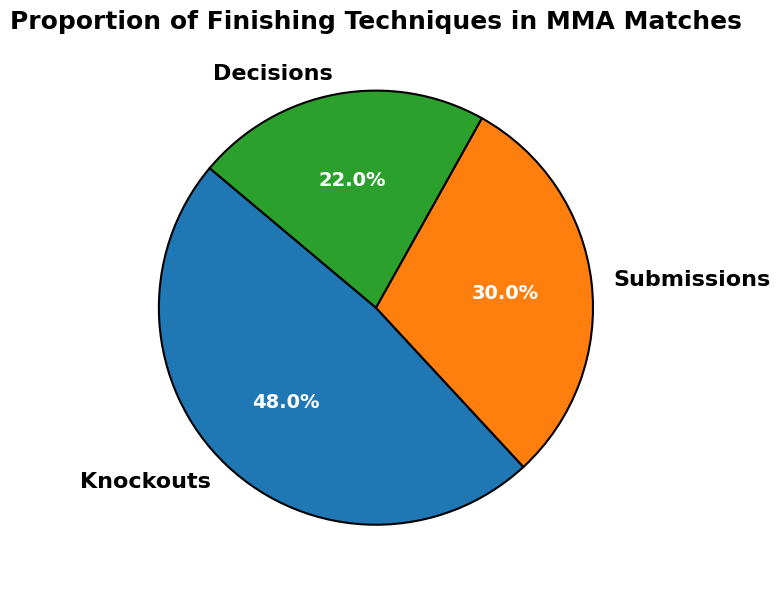What proportion of MMA matches end in decisions? The pie chart shows a segment labeled as "Decisions," which accounts for 22%.
Answer: 22% Which finishing technique is most common in MMA matches? According to the pie chart, the largest segment corresponds to "Knockouts," which is 48%.
Answer: Knockouts How much higher is the proportion of knockouts compared to submissions? From the pie chart, knockouts are 48% and submissions are 30%. Subtracting these values gives 48% - 30% = 18%.
Answer: 18% What is the combined proportion of matches that end in knockouts or submissions? Adding the proportions for knockouts (48%) and submissions (30%) gives 48% + 30% = 78%.
Answer: 78% Which of the finishing techniques has the smallest proportion? The smallest segment in the pie chart is labeled as "Decisions," which is 22%.
Answer: Decisions How do the colors of the segments aid in distinguishing between the finishing techniques? The pie chart uses distinct colors for each segment: one for knockouts, another for submissions, and a third for decisions. These visual differences help in easily identifying and distinguishing the proportions of each technique.
Answer: Distinct colors By how many percentage points do knockouts exceed decisions? According to the pie chart, knockouts are 48% and decisions are 22%. The difference is 48% - 22% = 26%.
Answer: 26% Rank the finishing techniques from most to least common based on the proportions. Observing the pie chart, the segments show the following proportions: Knockouts (48%), Submissions (30%), and Decisions (22%). Hence, the ranking is Knockouts > Submissions > Decisions.
Answer: Knockouts > Submissions > Decisions If the proportions of knockouts and submissions were switched, what would be the new proportion for submissions? If knockouts and submissions proportions were switched, submissions would be 48%, which is the current proportion for knockouts.
Answer: 48% What technique is represented by the middle-sized segment? In the pie chart, the middle-sized segment corresponds to "Submissions," which has a proportion of 30%.
Answer: Submissions 